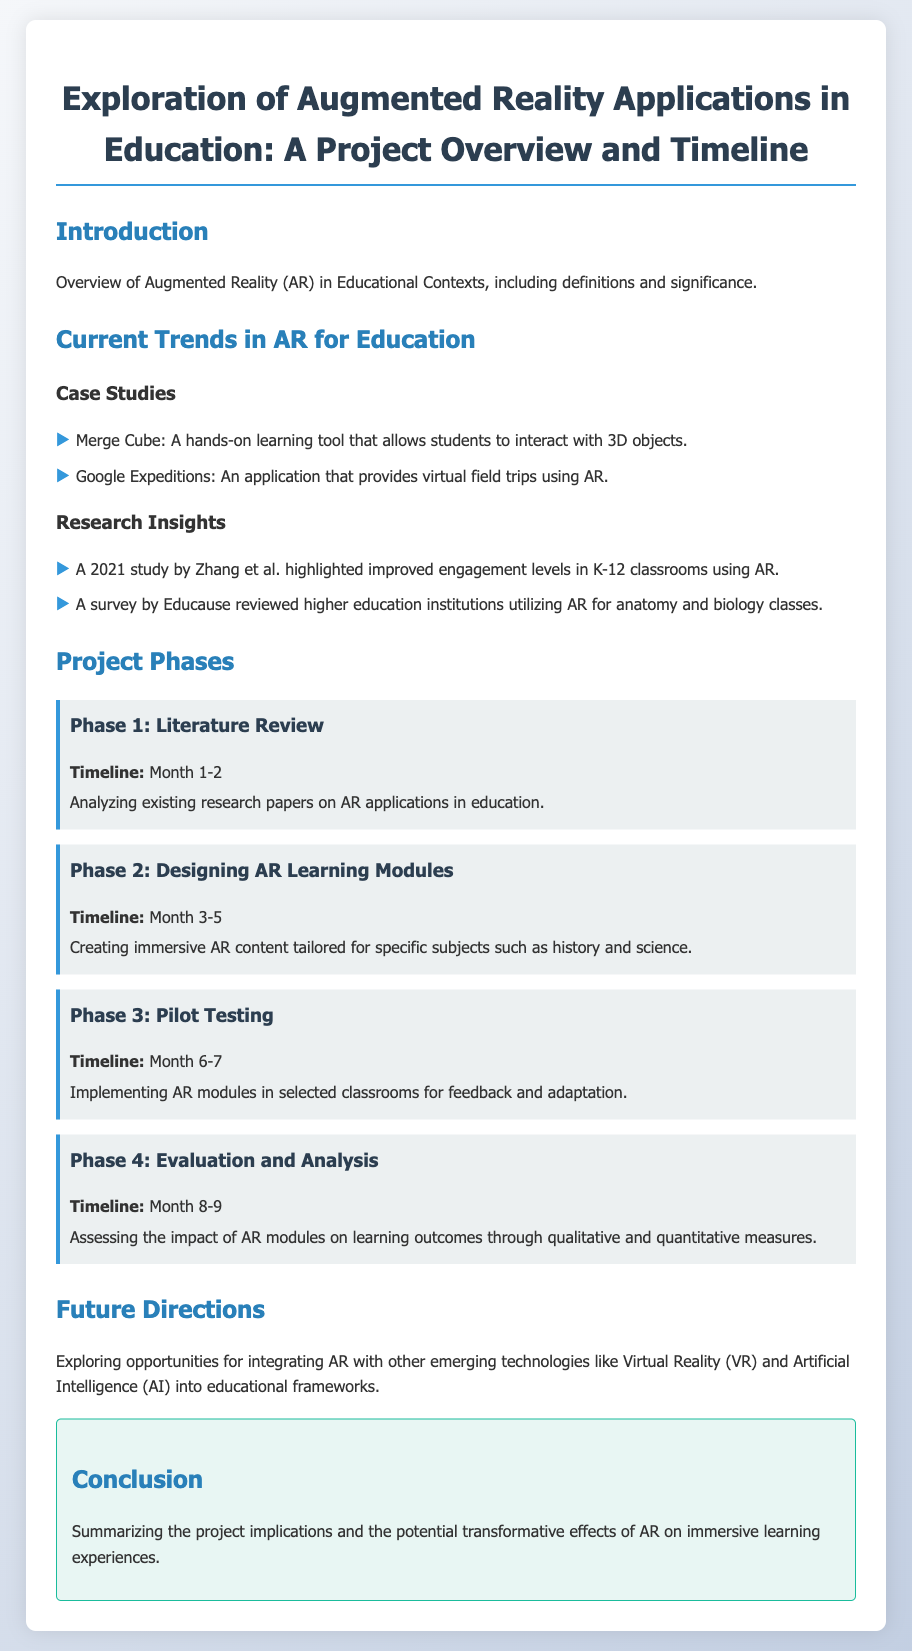What is the title of the project? The title provides the main focus of the document and is included prominently at the top.
Answer: Exploration of Augmented Reality Applications in Education: A Project Overview and Timeline What are the two case studies mentioned under Current Trends? These are specific examples highlighting how AR is currently being applied in education, listed in the case studies section.
Answer: Merge Cube and Google Expeditions How long is Phase 1 scheduled to last? The timeline for each project phase is provided to give a clear duration for the activities outlined.
Answer: Month 1-2 What is the main objective of Phase 4? This phase's purpose is defined to understand what outcomes the project aims to evaluate.
Answer: Assessing the impact of AR modules on learning outcomes What emerging technologies are suggested for future integration with AR? The document discusses possibilities for developing educational AR further by combining it with other technologies.
Answer: Virtual Reality and Artificial Intelligence Which study highlighted improved engagement in K-12 classrooms? This question asks for a specific study mentioned in the research insights section of the document.
Answer: A 2021 study by Zhang et al What type of content will be created during Phase 2? The type of content being produced is crucial for understanding the educational focus of the project.
Answer: Immersive AR content tailored for specific subjects What kind of measures will be used to assess impact in Phase 4? This asks for the type of evaluations that will be included in the analysis phase of the project.
Answer: Qualitative and quantitative measures 